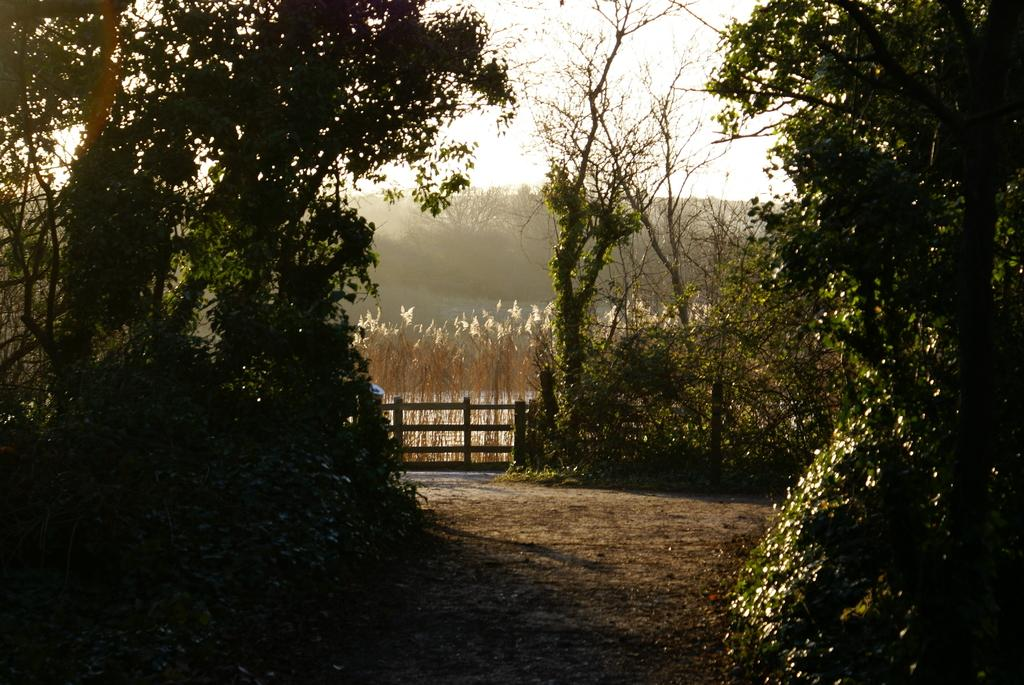What is the main feature of the image? There is a walkway in the image. What can be seen on both sides of the walkway? There are trees on both sides of the walkway. What is visible in the background of the image? There is a fence and a mountain in the background of the image. How would you describe the sky in the image? The sky is clear in the image. What type of muscle can be seen flexing in the image? There is no muscle visible in the image; it features a walkway with trees, a fence, and a mountain in the background. Is there an airplane flying in the image? No, there is no airplane present in the image. 